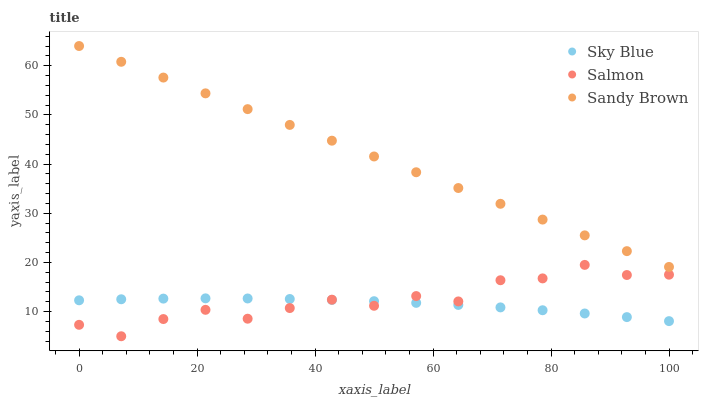Does Sky Blue have the minimum area under the curve?
Answer yes or no. Yes. Does Sandy Brown have the maximum area under the curve?
Answer yes or no. Yes. Does Salmon have the minimum area under the curve?
Answer yes or no. No. Does Salmon have the maximum area under the curve?
Answer yes or no. No. Is Sandy Brown the smoothest?
Answer yes or no. Yes. Is Salmon the roughest?
Answer yes or no. Yes. Is Salmon the smoothest?
Answer yes or no. No. Is Sandy Brown the roughest?
Answer yes or no. No. Does Salmon have the lowest value?
Answer yes or no. Yes. Does Sandy Brown have the lowest value?
Answer yes or no. No. Does Sandy Brown have the highest value?
Answer yes or no. Yes. Does Salmon have the highest value?
Answer yes or no. No. Is Salmon less than Sandy Brown?
Answer yes or no. Yes. Is Sandy Brown greater than Salmon?
Answer yes or no. Yes. Does Salmon intersect Sky Blue?
Answer yes or no. Yes. Is Salmon less than Sky Blue?
Answer yes or no. No. Is Salmon greater than Sky Blue?
Answer yes or no. No. Does Salmon intersect Sandy Brown?
Answer yes or no. No. 